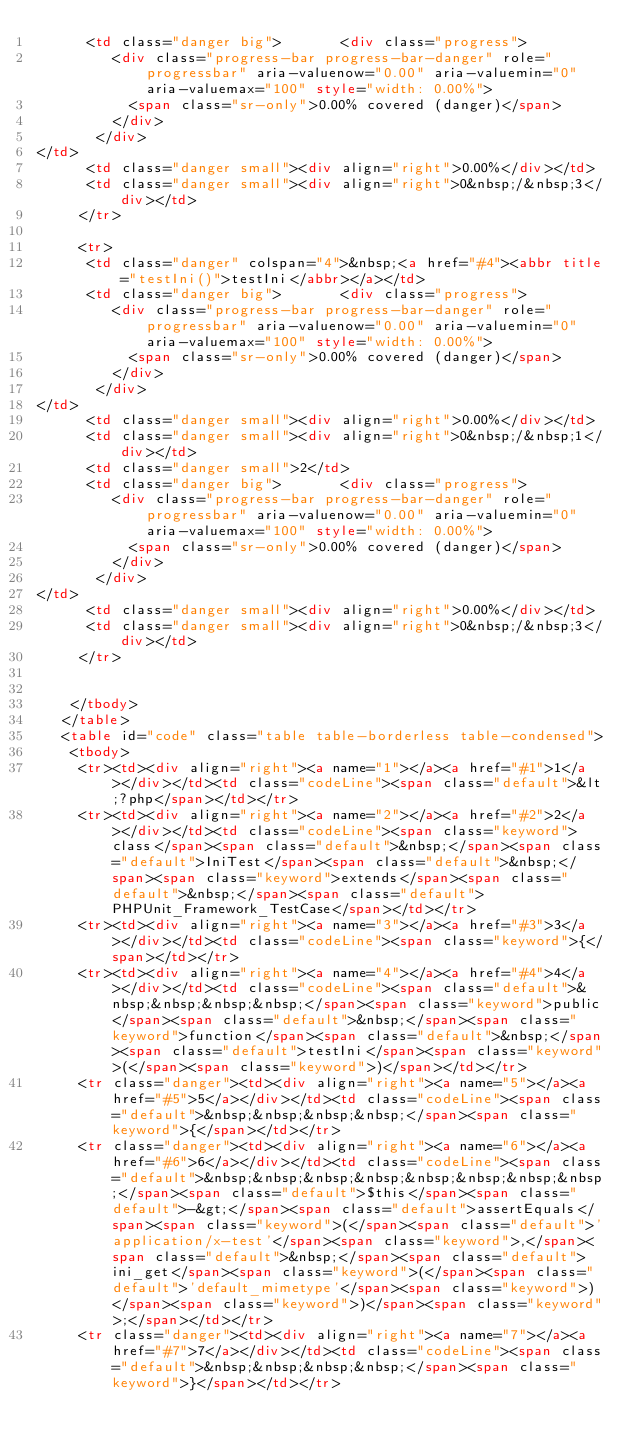Convert code to text. <code><loc_0><loc_0><loc_500><loc_500><_HTML_>      <td class="danger big">       <div class="progress">
         <div class="progress-bar progress-bar-danger" role="progressbar" aria-valuenow="0.00" aria-valuemin="0" aria-valuemax="100" style="width: 0.00%">
           <span class="sr-only">0.00% covered (danger)</span>
         </div>
       </div>
</td>
      <td class="danger small"><div align="right">0.00%</div></td>
      <td class="danger small"><div align="right">0&nbsp;/&nbsp;3</div></td>
     </tr>

     <tr>
      <td class="danger" colspan="4">&nbsp;<a href="#4"><abbr title="testIni()">testIni</abbr></a></td>
      <td class="danger big">       <div class="progress">
         <div class="progress-bar progress-bar-danger" role="progressbar" aria-valuenow="0.00" aria-valuemin="0" aria-valuemax="100" style="width: 0.00%">
           <span class="sr-only">0.00% covered (danger)</span>
         </div>
       </div>
</td>
      <td class="danger small"><div align="right">0.00%</div></td>
      <td class="danger small"><div align="right">0&nbsp;/&nbsp;1</div></td>
      <td class="danger small">2</td>
      <td class="danger big">       <div class="progress">
         <div class="progress-bar progress-bar-danger" role="progressbar" aria-valuenow="0.00" aria-valuemin="0" aria-valuemax="100" style="width: 0.00%">
           <span class="sr-only">0.00% covered (danger)</span>
         </div>
       </div>
</td>
      <td class="danger small"><div align="right">0.00%</div></td>
      <td class="danger small"><div align="right">0&nbsp;/&nbsp;3</div></td>
     </tr>


    </tbody>
   </table>
   <table id="code" class="table table-borderless table-condensed">
    <tbody>
     <tr><td><div align="right"><a name="1"></a><a href="#1">1</a></div></td><td class="codeLine"><span class="default">&lt;?php</span></td></tr>
     <tr><td><div align="right"><a name="2"></a><a href="#2">2</a></div></td><td class="codeLine"><span class="keyword">class</span><span class="default">&nbsp;</span><span class="default">IniTest</span><span class="default">&nbsp;</span><span class="keyword">extends</span><span class="default">&nbsp;</span><span class="default">PHPUnit_Framework_TestCase</span></td></tr>
     <tr><td><div align="right"><a name="3"></a><a href="#3">3</a></div></td><td class="codeLine"><span class="keyword">{</span></td></tr>
     <tr><td><div align="right"><a name="4"></a><a href="#4">4</a></div></td><td class="codeLine"><span class="default">&nbsp;&nbsp;&nbsp;&nbsp;</span><span class="keyword">public</span><span class="default">&nbsp;</span><span class="keyword">function</span><span class="default">&nbsp;</span><span class="default">testIni</span><span class="keyword">(</span><span class="keyword">)</span></td></tr>
     <tr class="danger"><td><div align="right"><a name="5"></a><a href="#5">5</a></div></td><td class="codeLine"><span class="default">&nbsp;&nbsp;&nbsp;&nbsp;</span><span class="keyword">{</span></td></tr>
     <tr class="danger"><td><div align="right"><a name="6"></a><a href="#6">6</a></div></td><td class="codeLine"><span class="default">&nbsp;&nbsp;&nbsp;&nbsp;&nbsp;&nbsp;&nbsp;&nbsp;</span><span class="default">$this</span><span class="default">-&gt;</span><span class="default">assertEquals</span><span class="keyword">(</span><span class="default">'application/x-test'</span><span class="keyword">,</span><span class="default">&nbsp;</span><span class="default">ini_get</span><span class="keyword">(</span><span class="default">'default_mimetype'</span><span class="keyword">)</span><span class="keyword">)</span><span class="keyword">;</span></td></tr>
     <tr class="danger"><td><div align="right"><a name="7"></a><a href="#7">7</a></div></td><td class="codeLine"><span class="default">&nbsp;&nbsp;&nbsp;&nbsp;</span><span class="keyword">}</span></td></tr></code> 